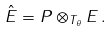<formula> <loc_0><loc_0><loc_500><loc_500>\hat { E } = P \otimes _ { T _ { \theta } } E \, .</formula> 